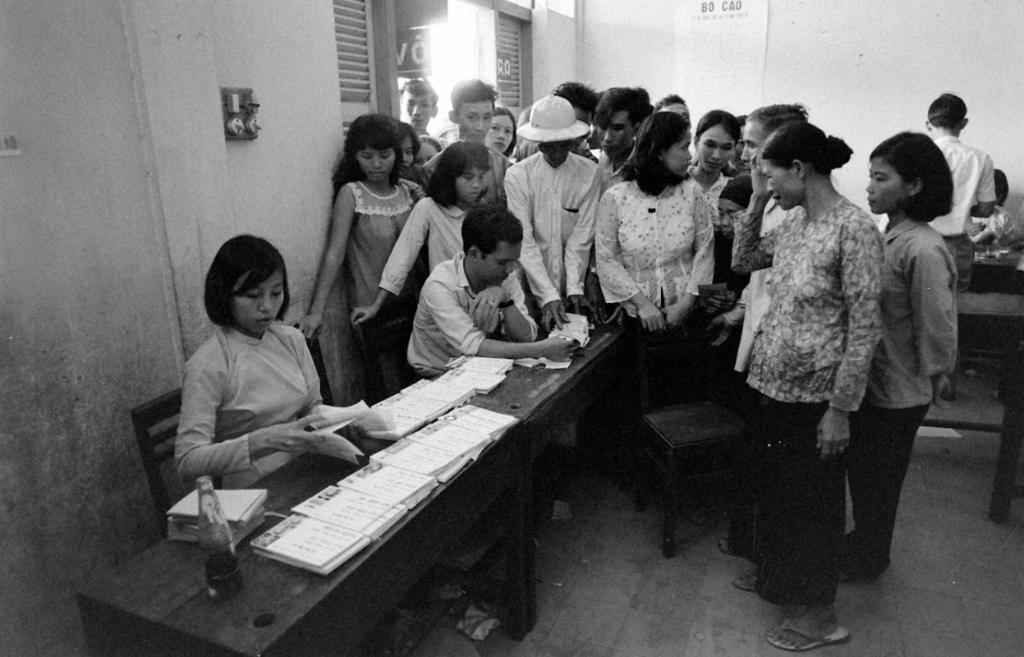How many people are in the image? There are people in the image, but the exact number is not specified. What are the people in the image doing? Some people are standing, while others are sitting. What is on the table in the image? There are papers on the table. What shape is the zinc taking in the image? There is no mention of zinc or any specific shape in the image. Is there an advertisement visible in the image? The facts provided do not mention an advertisement, so we cannot determine if one is present in the image. 